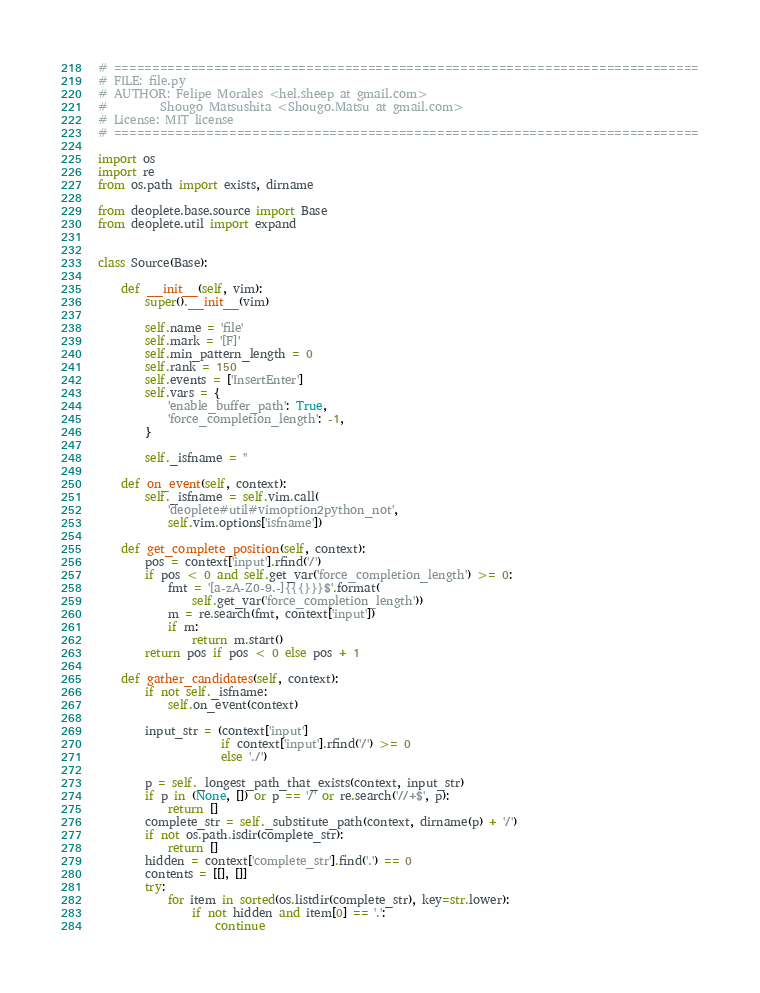<code> <loc_0><loc_0><loc_500><loc_500><_Python_># ============================================================================
# FILE: file.py
# AUTHOR: Felipe Morales <hel.sheep at gmail.com>
#         Shougo Matsushita <Shougo.Matsu at gmail.com>
# License: MIT license
# ============================================================================

import os
import re
from os.path import exists, dirname

from deoplete.base.source import Base
from deoplete.util import expand


class Source(Base):

    def __init__(self, vim):
        super().__init__(vim)

        self.name = 'file'
        self.mark = '[F]'
        self.min_pattern_length = 0
        self.rank = 150
        self.events = ['InsertEnter']
        self.vars = {
            'enable_buffer_path': True,
            'force_completion_length': -1,
        }

        self._isfname = ''

    def on_event(self, context):
        self._isfname = self.vim.call(
            'deoplete#util#vimoption2python_not',
            self.vim.options['isfname'])

    def get_complete_position(self, context):
        pos = context['input'].rfind('/')
        if pos < 0 and self.get_var('force_completion_length') >= 0:
            fmt = '[a-zA-Z0-9.-]{{{}}}$'.format(
                self.get_var('force_completion_length'))
            m = re.search(fmt, context['input'])
            if m:
                return m.start()
        return pos if pos < 0 else pos + 1

    def gather_candidates(self, context):
        if not self._isfname:
            self.on_event(context)

        input_str = (context['input']
                     if context['input'].rfind('/') >= 0
                     else './')

        p = self._longest_path_that_exists(context, input_str)
        if p in (None, []) or p == '/' or re.search('//+$', p):
            return []
        complete_str = self._substitute_path(context, dirname(p) + '/')
        if not os.path.isdir(complete_str):
            return []
        hidden = context['complete_str'].find('.') == 0
        contents = [[], []]
        try:
            for item in sorted(os.listdir(complete_str), key=str.lower):
                if not hidden and item[0] == '.':
                    continue</code> 